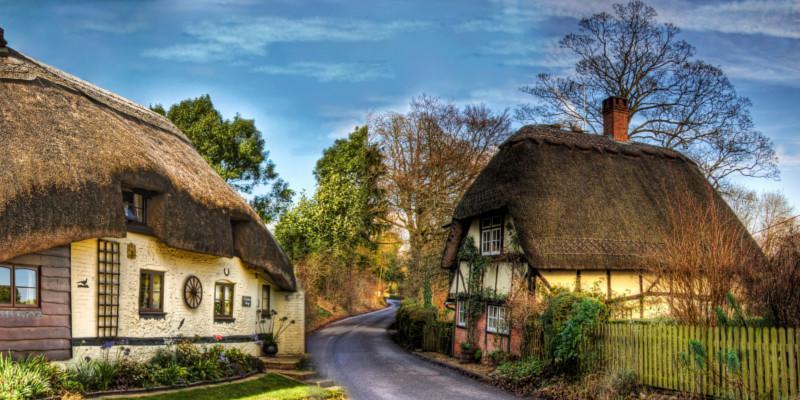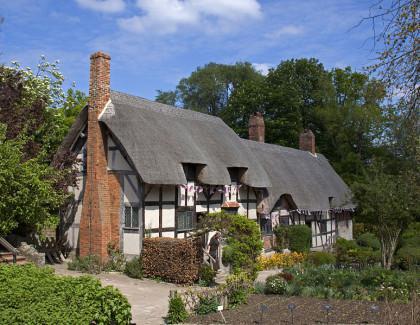The first image is the image on the left, the second image is the image on the right. Examine the images to the left and right. Is the description "In at least one image there is a white house with black strip trim." accurate? Answer yes or no. Yes. The first image is the image on the left, the second image is the image on the right. Analyze the images presented: Is the assertion "Each house shows only one chimney" valid? Answer yes or no. No. 